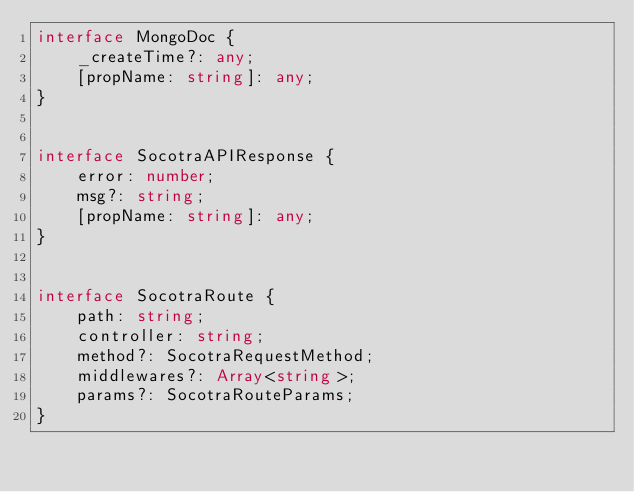<code> <loc_0><loc_0><loc_500><loc_500><_TypeScript_>interface MongoDoc {
    _createTime?: any;
    [propName: string]: any;
}


interface SocotraAPIResponse {
    error: number;
    msg?: string;
    [propName: string]: any;
}


interface SocotraRoute {
    path: string;
    controller: string;
    method?: SocotraRequestMethod;
    middlewares?: Array<string>;
    params?: SocotraRouteParams;
}

</code> 